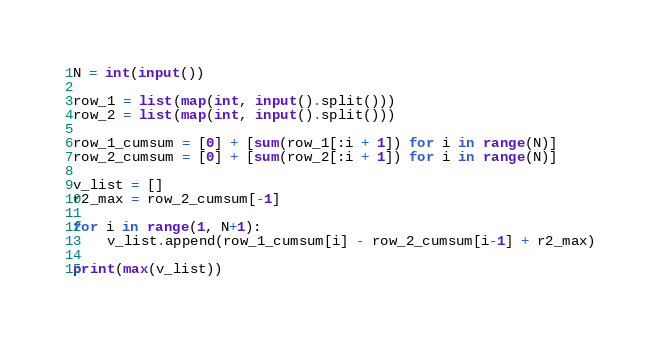Convert code to text. <code><loc_0><loc_0><loc_500><loc_500><_Python_>N = int(input())

row_1 = list(map(int, input().split()))
row_2 = list(map(int, input().split()))

row_1_cumsum = [0] + [sum(row_1[:i + 1]) for i in range(N)]
row_2_cumsum = [0] + [sum(row_2[:i + 1]) for i in range(N)]

v_list = []
r2_max = row_2_cumsum[-1]

for i in range(1, N+1):
    v_list.append(row_1_cumsum[i] - row_2_cumsum[i-1] + r2_max)

print(max(v_list))
</code> 